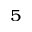<formula> <loc_0><loc_0><loc_500><loc_500>^ { 5 }</formula> 